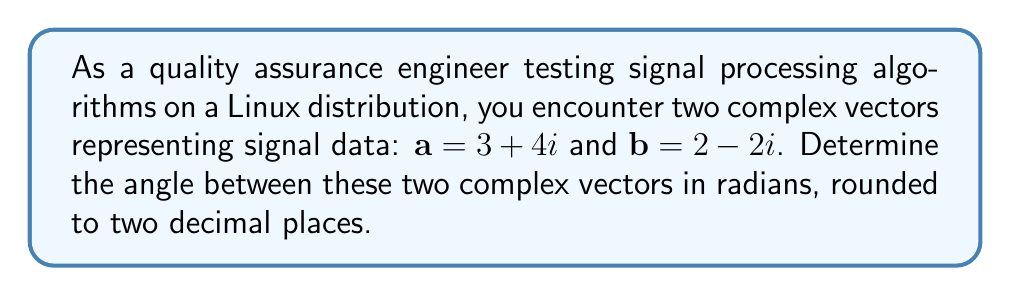Help me with this question. To find the angle between two complex vectors, we can use the dot product formula:

$$\cos \theta = \frac{\mathbf{a} \cdot \mathbf{b}}{|\mathbf{a}||\mathbf{b}|}$$

Where $\mathbf{a} \cdot \mathbf{b}$ is the dot product of the vectors, and $|\mathbf{a}|$ and $|\mathbf{b}|$ are their magnitudes.

Step 1: Calculate the dot product
The dot product of two complex vectors $\mathbf{a} = a_1 + b_1i$ and $\mathbf{b} = a_2 + b_2i$ is given by:
$$\mathbf{a} \cdot \mathbf{b} = a_1a_2 + b_1b_2$$

For our vectors:
$$\mathbf{a} \cdot \mathbf{b} = (3 \times 2) + (4 \times -2) = 6 - 8 = -2$$

Step 2: Calculate the magnitudes
The magnitude of a complex vector $\mathbf{z} = x + yi$ is given by $|\mathbf{z}| = \sqrt{x^2 + y^2}$

For $\mathbf{a}$: $|\mathbf{a}| = \sqrt{3^2 + 4^2} = \sqrt{25} = 5$
For $\mathbf{b}$: $|\mathbf{b}| = \sqrt{2^2 + (-2)^2} = \sqrt{8} = 2\sqrt{2}$

Step 3: Apply the dot product formula
$$\cos \theta = \frac{-2}{5 \times 2\sqrt{2}} = -\frac{1}{5\sqrt{2}}$$

Step 4: Take the inverse cosine (arccos) of both sides
$$\theta = \arccos(-\frac{1}{5\sqrt{2}})$$

Step 5: Calculate the result and round to two decimal places
Using a calculator or a computational tool available in the Linux environment:
$$\theta \approx 1.82 \text{ radians}$$
Answer: $1.82 \text{ radians}$ 